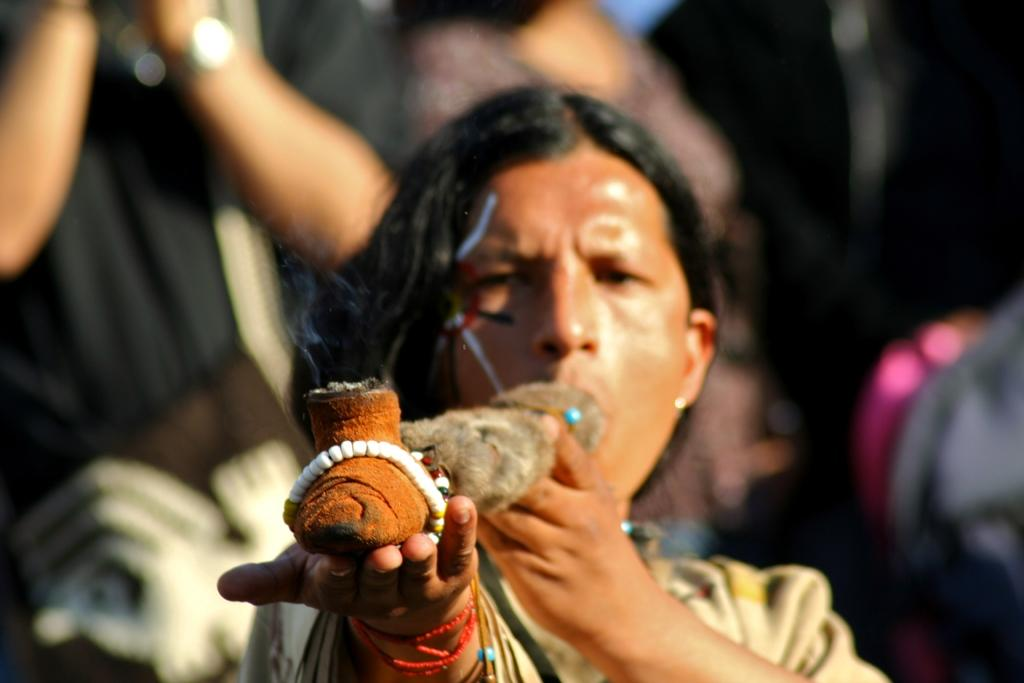What is the person in the image holding? The person in the image is holding an object. Can you describe the background of the image? The background of the image is blurred. Are there any other people visible in the image? Yes, there are people visible in the background of the image. How many dogs are present in the image? There are no dogs present in the image. What type of representative can be seen in the image? There is no representative present in the image. 